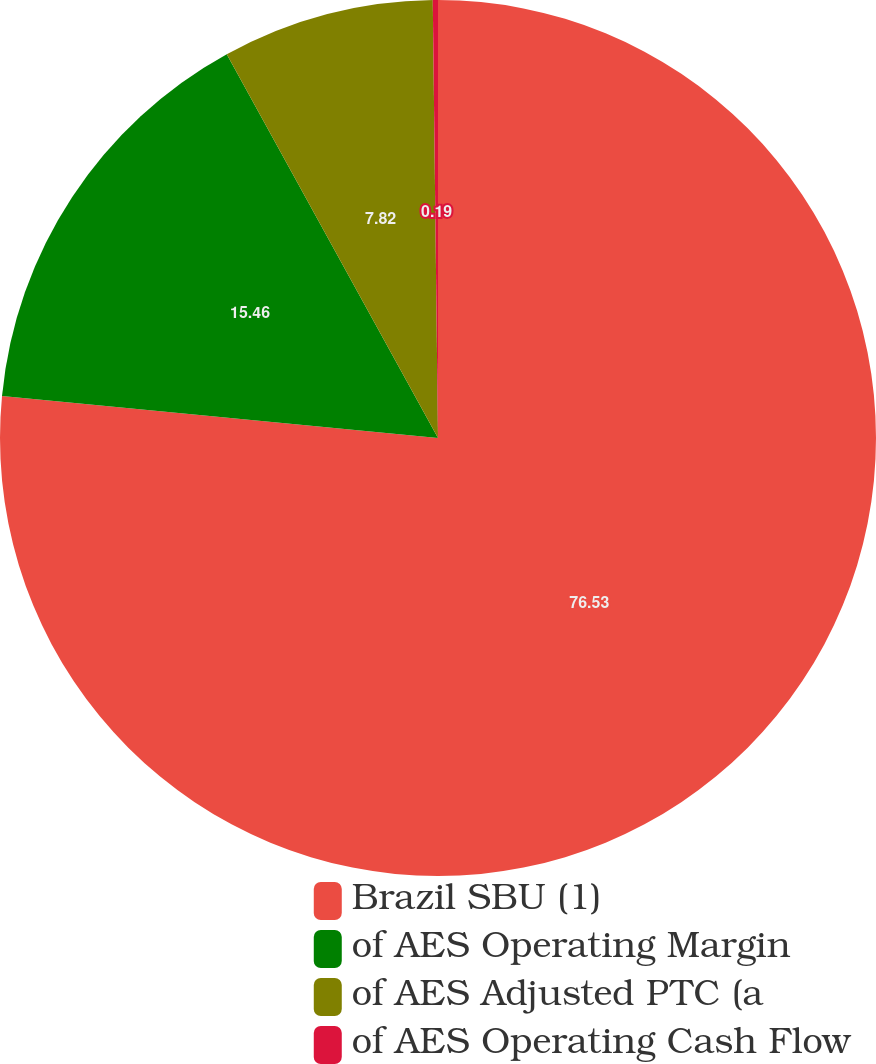Convert chart to OTSL. <chart><loc_0><loc_0><loc_500><loc_500><pie_chart><fcel>Brazil SBU (1)<fcel>of AES Operating Margin<fcel>of AES Adjusted PTC (a<fcel>of AES Operating Cash Flow<nl><fcel>76.53%<fcel>15.46%<fcel>7.82%<fcel>0.19%<nl></chart> 